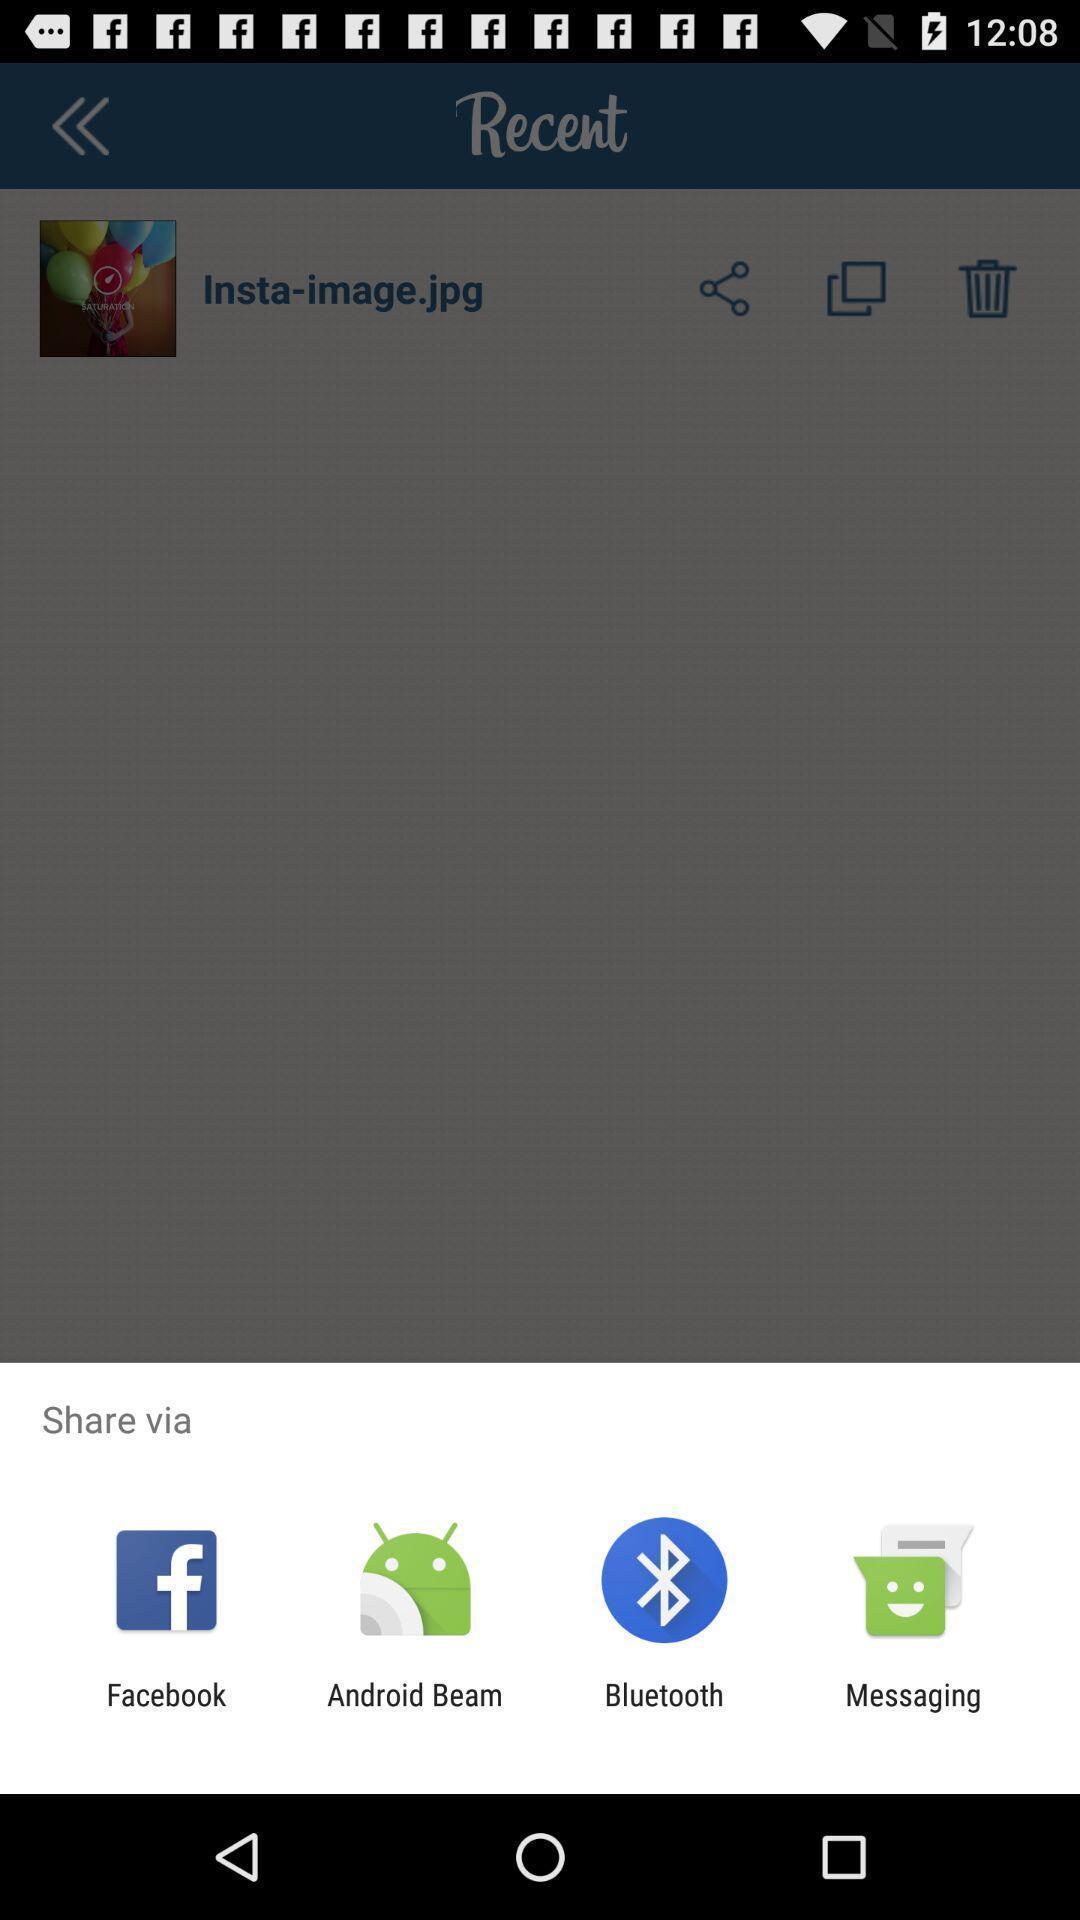Describe this image in words. Pop-up to share image via different apps. 